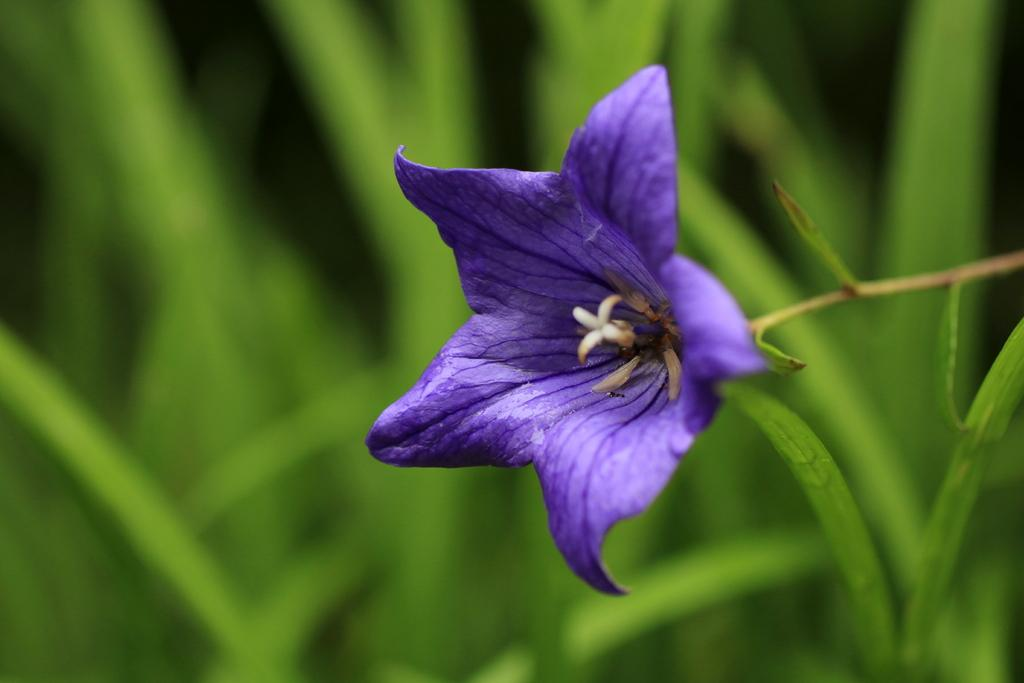What type of flower is in the image? There is a violet color flower in the image. How is the flower attached to the plant? The flower is on a stem. What color is the background of the image? The background of the image is green and blurry. Can you see a hand holding the flower in the image? No, there is no hand holding the flower in the image. What type of straw is used to water the flower in the image? There is no straw present in the image, and the image does not show the flower being watered. 